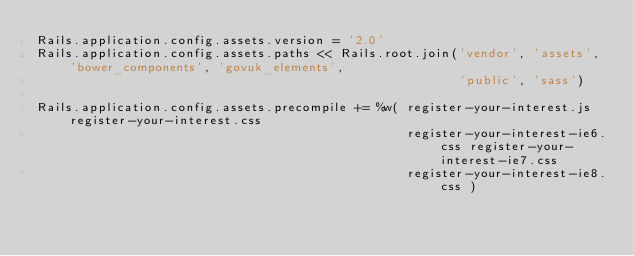<code> <loc_0><loc_0><loc_500><loc_500><_Ruby_>Rails.application.config.assets.version = '2.0'
Rails.application.config.assets.paths << Rails.root.join('vendor', 'assets', 'bower_components', 'govuk_elements',
                                                         'public', 'sass')

Rails.application.config.assets.precompile += %w( register-your-interest.js register-your-interest.css
                                                  register-your-interest-ie6.css register-your-interest-ie7.css
                                                  register-your-interest-ie8.css )
</code> 